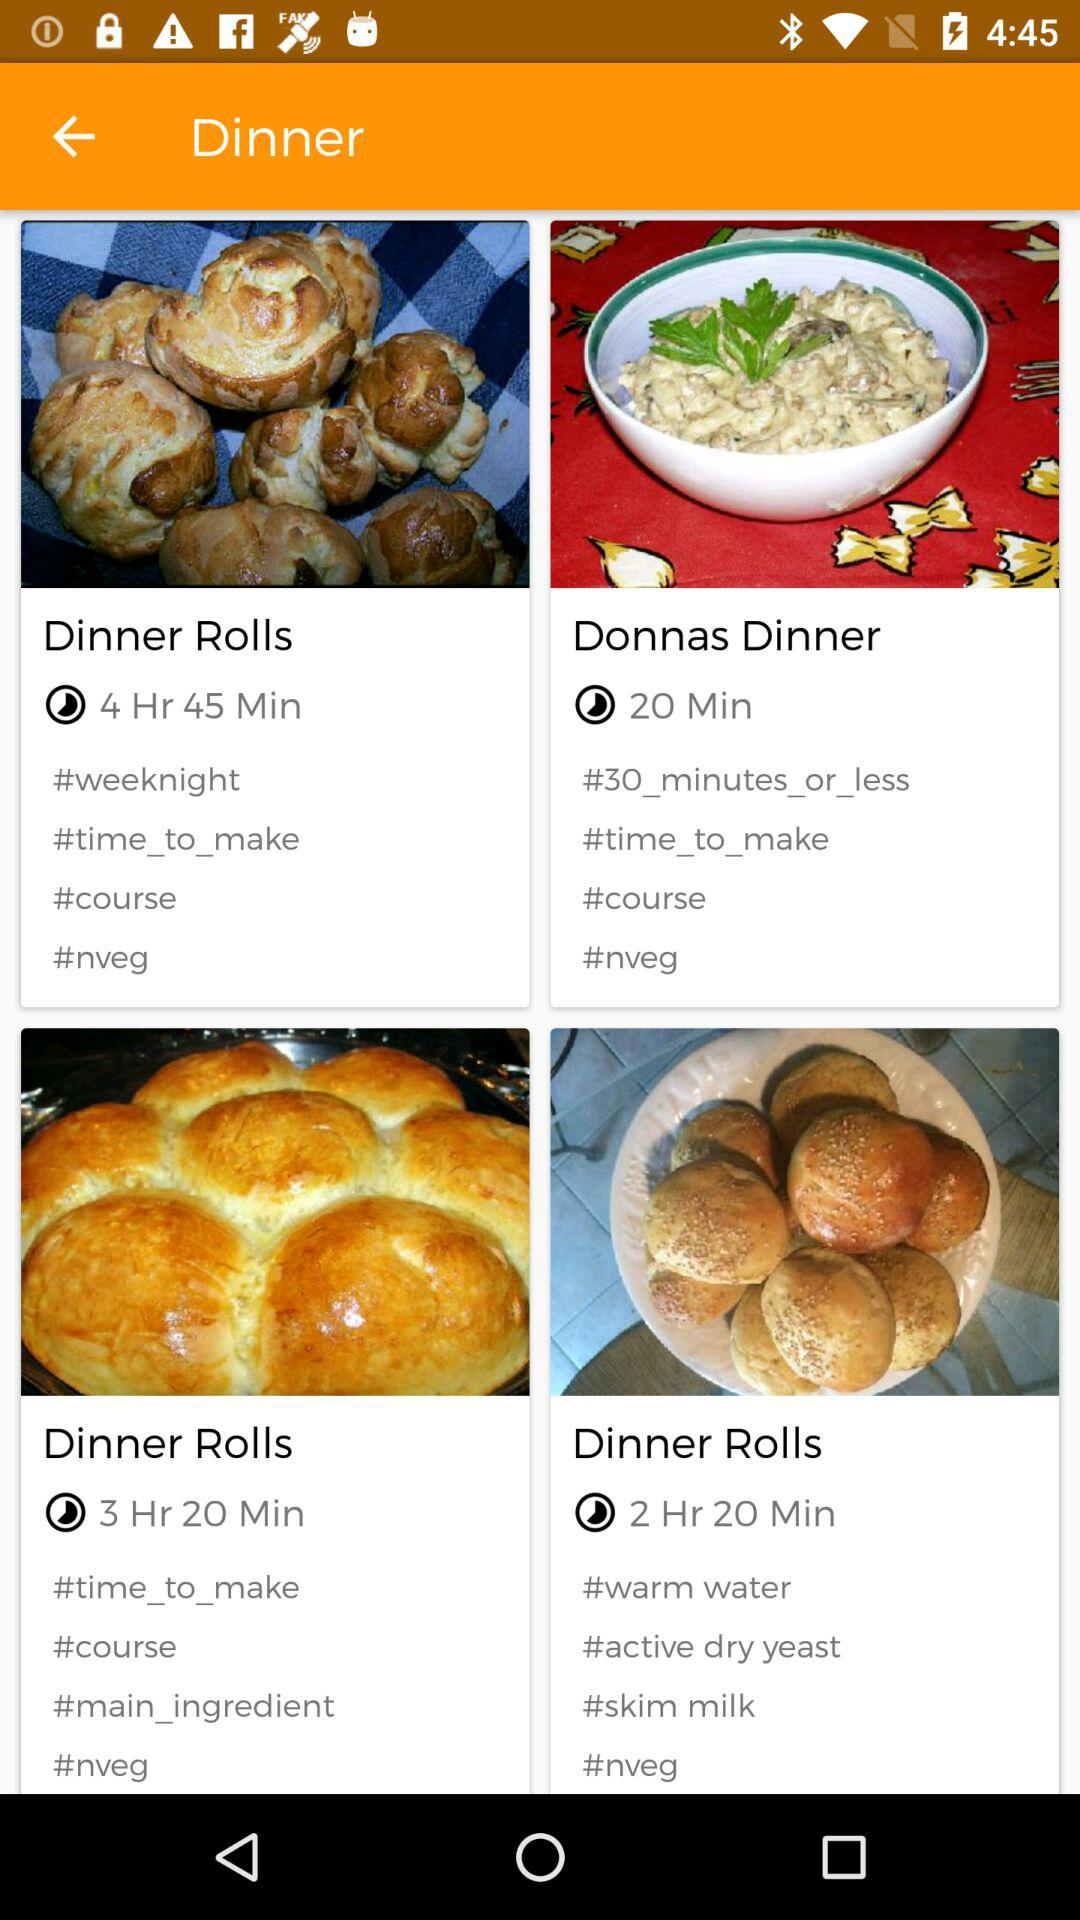How much time is required to make "Dinner Rolls", whose tag is "weeknight"? The required time is 4 hours and 45 minutes. 